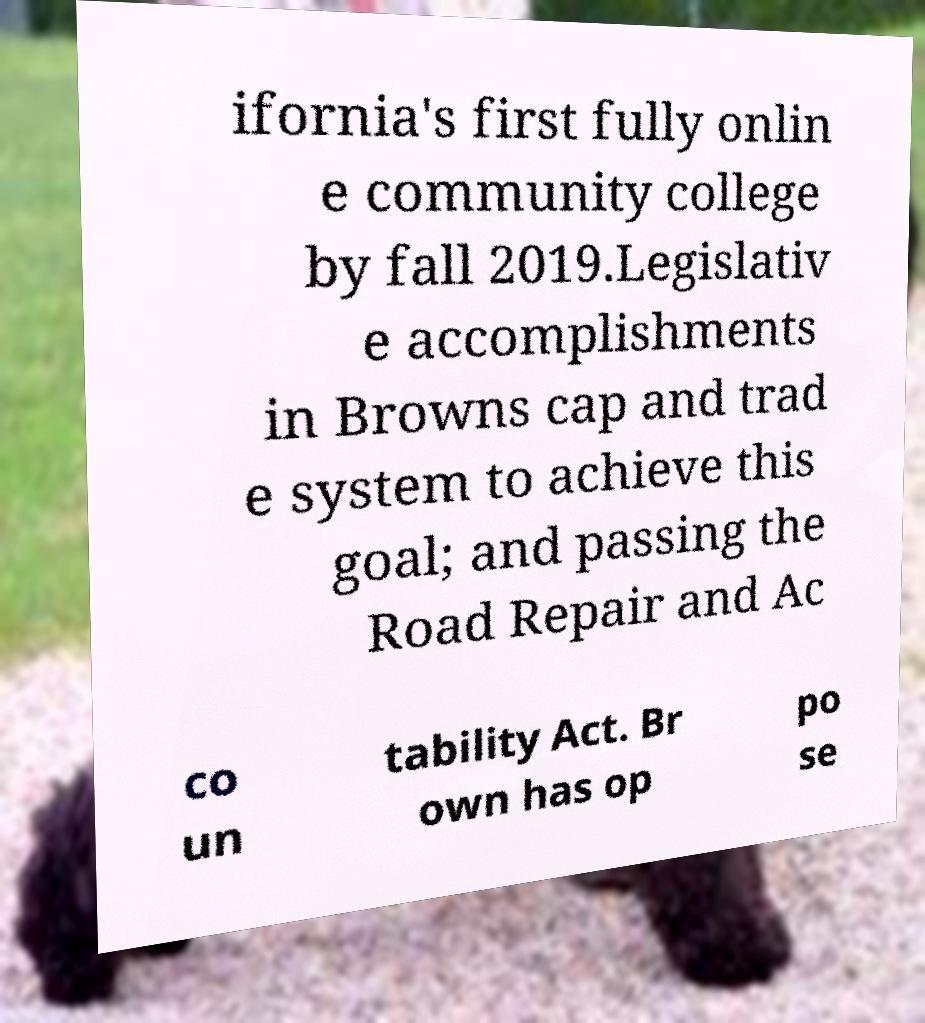Please read and relay the text visible in this image. What does it say? ifornia's first fully onlin e community college by fall 2019.Legislativ e accomplishments in Browns cap and trad e system to achieve this goal; and passing the Road Repair and Ac co un tability Act. Br own has op po se 